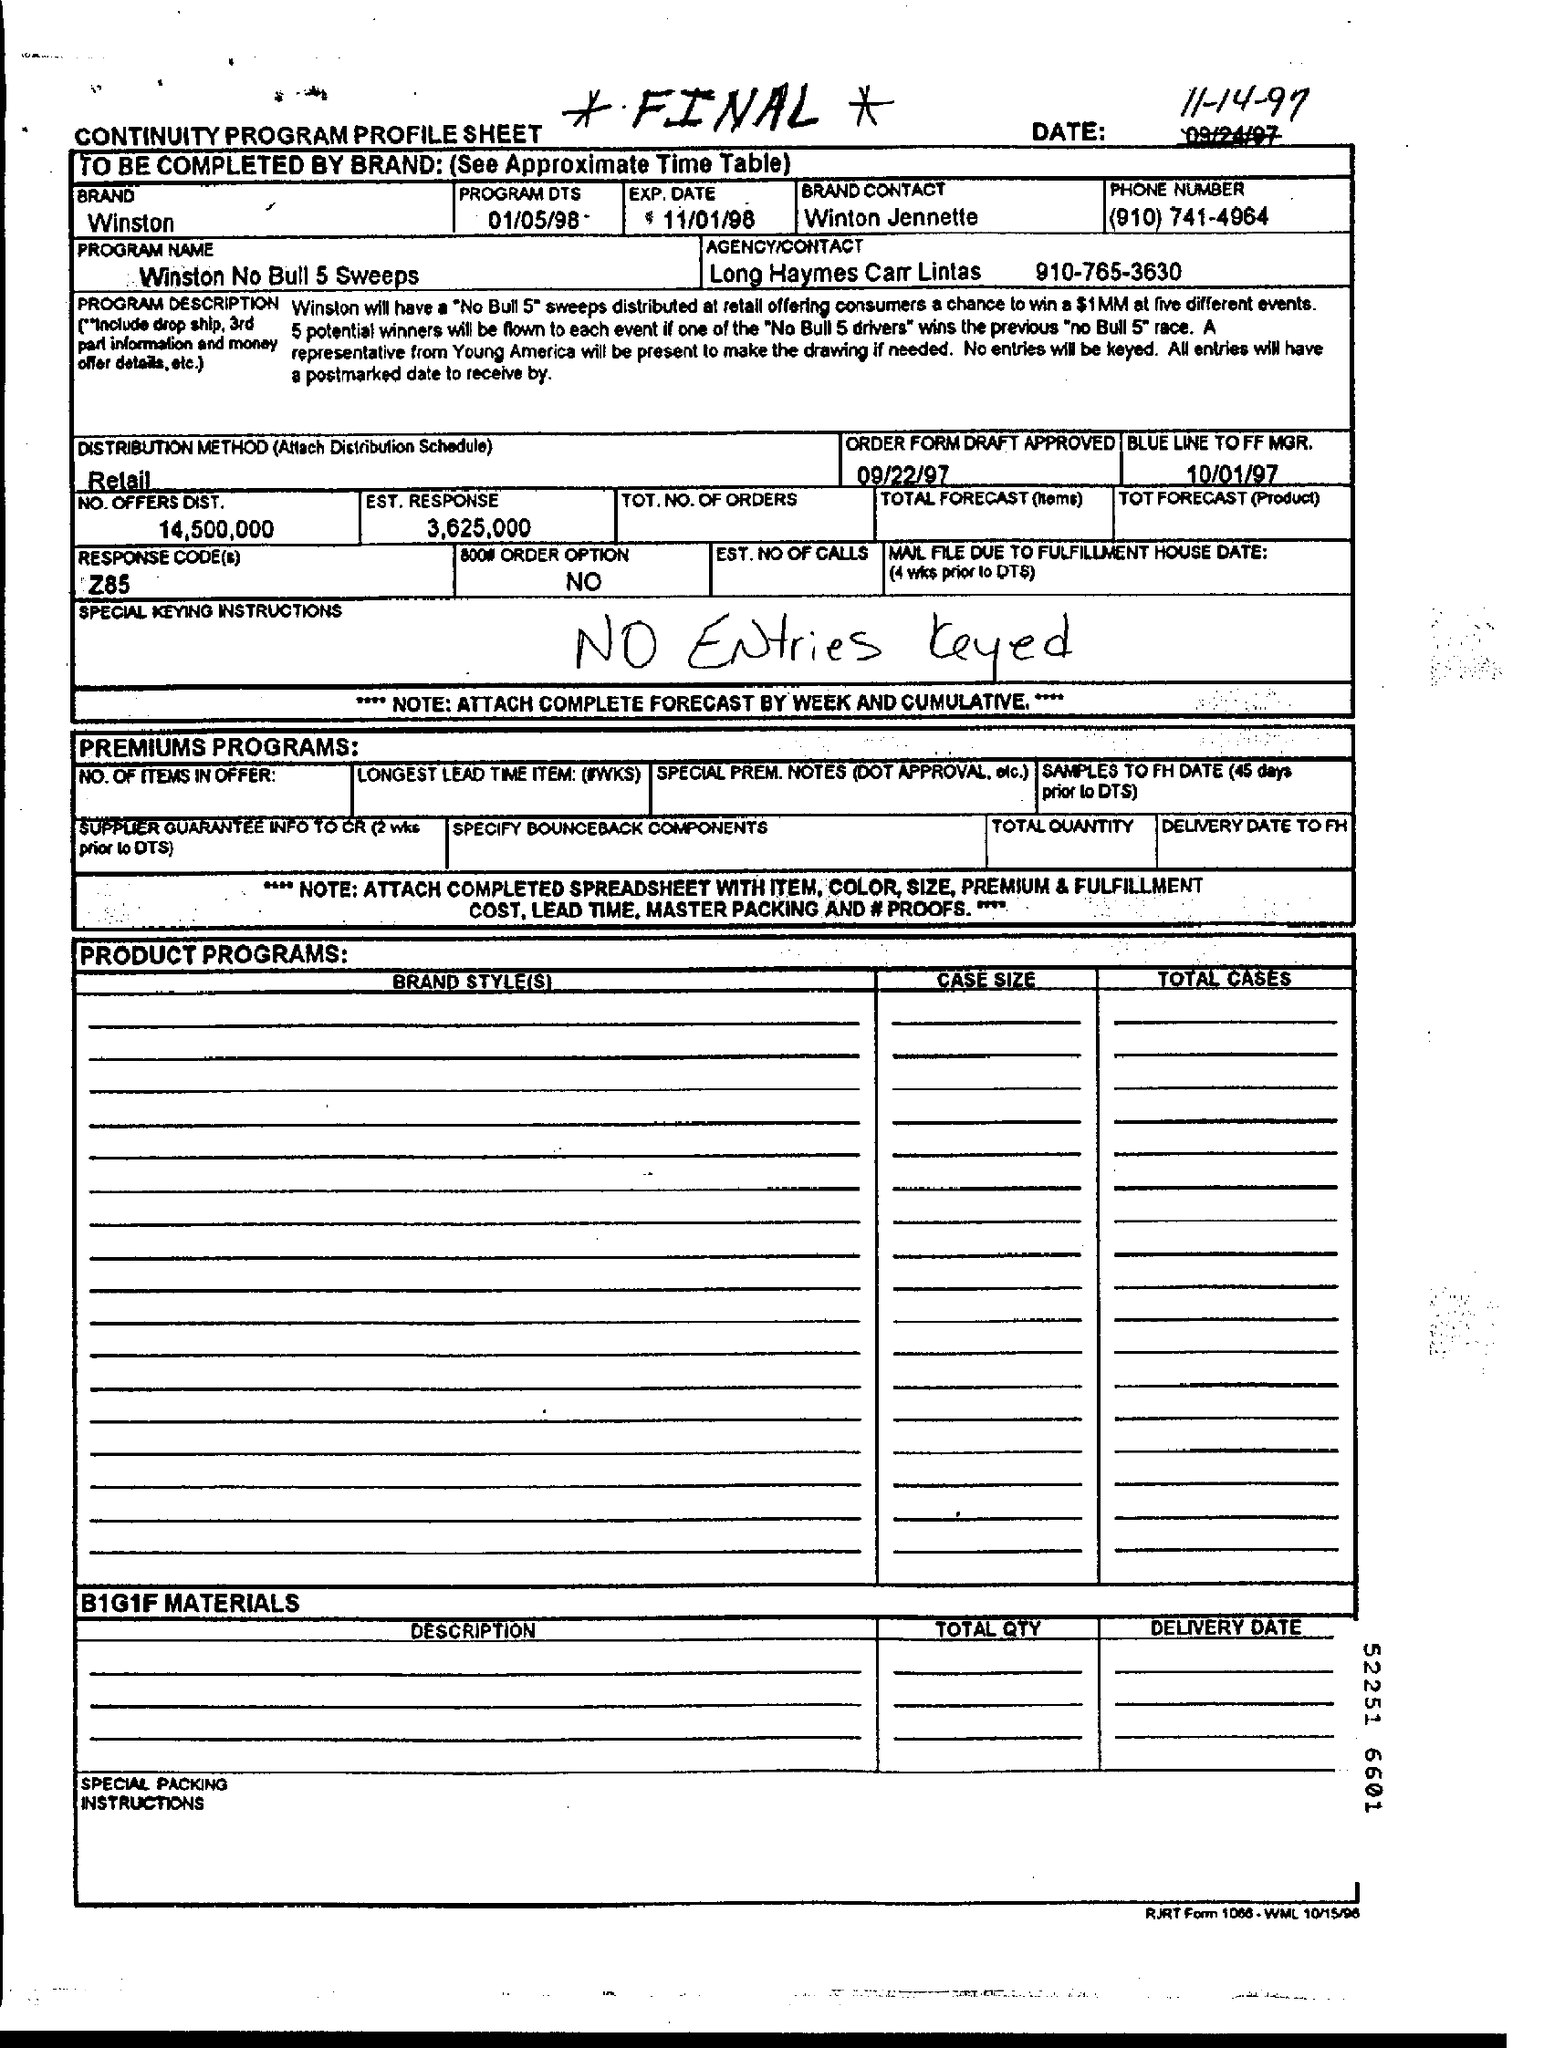What is the Program Name mentioned in this document?
Make the answer very short. Winston no bull 5 sweeps. Which Brand is mentioned in this document?
Offer a very short reply. Winston. Who is the Brand Contact person?
Provide a short and direct response. Winton jennette. What is the EXP. Date mentioned in the document?
Provide a short and direct response. 11/01/98. What is the Response Code Assigned?
Provide a short and direct response. Z85. What is the EST. Response as per the document?
Provide a succinct answer. 3625000. When is the order form draft approved?
Provide a short and direct response. 09/22/97. Which Distribution Method is used?
Offer a terse response. Retail. 